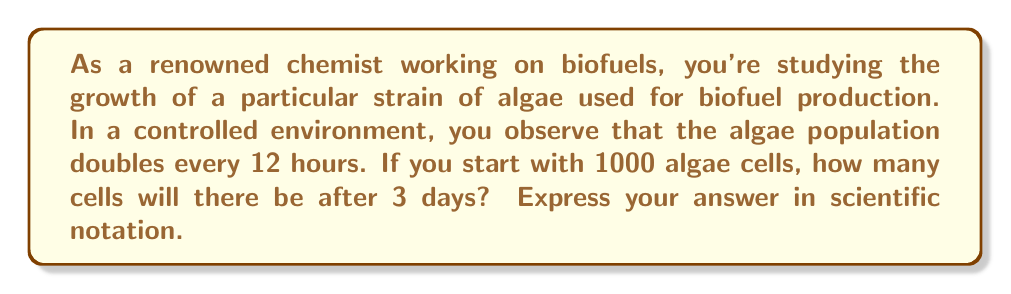Can you solve this math problem? Let's approach this step-by-step:

1) First, we need to determine how many doubling periods occur in 3 days:
   - 1 day = 24 hours
   - 3 days = 72 hours
   - Number of doubling periods = 72 hours ÷ 12 hours = 6 periods

2) We can express this as an exponential growth problem:
   $$ N = N_0 \cdot 2^t $$
   Where:
   $N$ = Final number of cells
   $N_0$ = Initial number of cells (1000)
   $2$ = Growth factor (population doubles each period)
   $t$ = Number of doubling periods (6)

3) Let's substitute these values:
   $$ N = 1000 \cdot 2^6 $$

4) Now, let's calculate:
   $$ N = 1000 \cdot 64 = 64,000 $$

5) To express this in scientific notation:
   $$ N = 6.4 \times 10^4 $$

This rapid growth demonstrates why algae are considered promising for biofuel production, as their biomass can increase quickly under optimal conditions.
Answer: $6.4 \times 10^4$ cells 